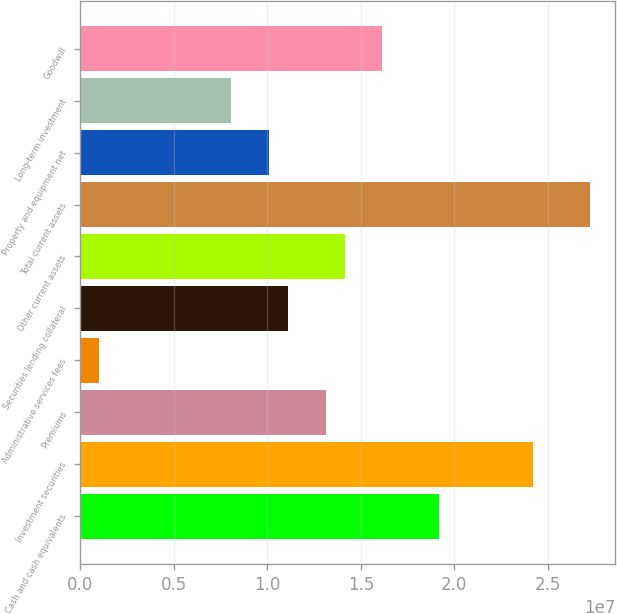Convert chart to OTSL. <chart><loc_0><loc_0><loc_500><loc_500><bar_chart><fcel>Cash and cash equivalents<fcel>Investment securities<fcel>Premiums<fcel>Administrative services fees<fcel>Securities lending collateral<fcel>Other current assets<fcel>Total current assets<fcel>Property and equipment net<fcel>Long-term investment<fcel>Goodwill<nl><fcel>1.91752e+07<fcel>2.42179e+07<fcel>1.31241e+07<fcel>1.02173e+06<fcel>1.1107e+07<fcel>1.41326e+07<fcel>2.72435e+07<fcel>1.00985e+07<fcel>8.08143e+06<fcel>1.61497e+07<nl></chart> 